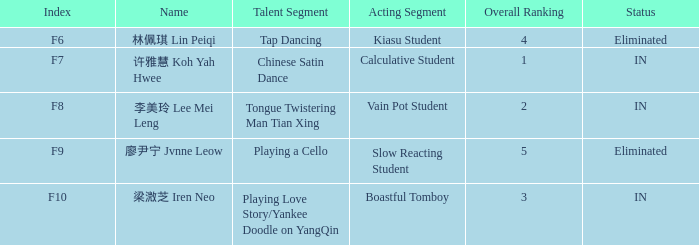For the event with index f9, what's the talent segment? Playing a Cello. 